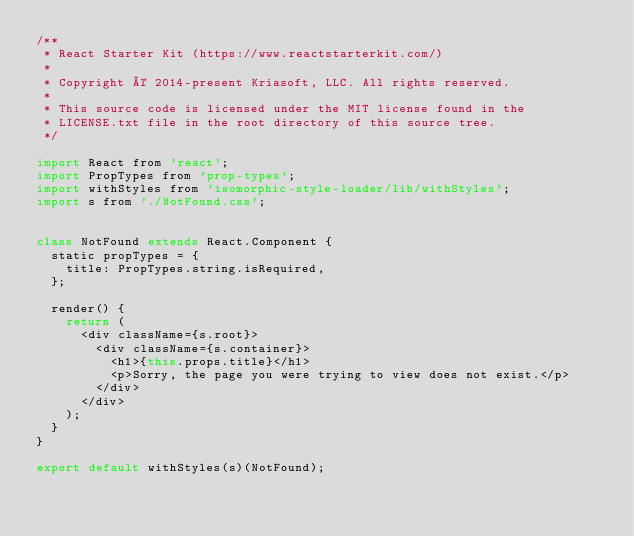<code> <loc_0><loc_0><loc_500><loc_500><_JavaScript_>/**
 * React Starter Kit (https://www.reactstarterkit.com/)
 *
 * Copyright © 2014-present Kriasoft, LLC. All rights reserved.
 *
 * This source code is licensed under the MIT license found in the
 * LICENSE.txt file in the root directory of this source tree.
 */

import React from 'react';
import PropTypes from 'prop-types';
import withStyles from 'isomorphic-style-loader/lib/withStyles';
import s from './NotFound.css';


class NotFound extends React.Component {
  static propTypes = {
    title: PropTypes.string.isRequired,
  };

  render() {
    return (
      <div className={s.root}>
        <div className={s.container}>
          <h1>{this.props.title}</h1>
          <p>Sorry, the page you were trying to view does not exist.</p>
        </div>
      </div>
    );
  }
}

export default withStyles(s)(NotFound);
</code> 